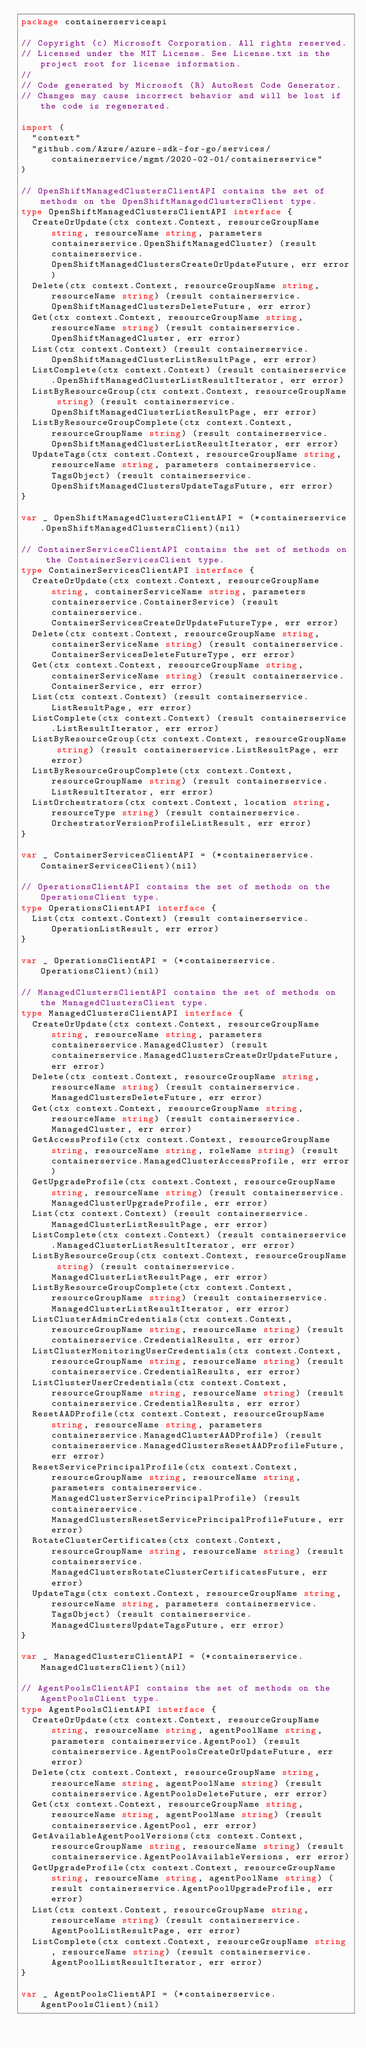Convert code to text. <code><loc_0><loc_0><loc_500><loc_500><_Go_>package containerserviceapi

// Copyright (c) Microsoft Corporation. All rights reserved.
// Licensed under the MIT License. See License.txt in the project root for license information.
//
// Code generated by Microsoft (R) AutoRest Code Generator.
// Changes may cause incorrect behavior and will be lost if the code is regenerated.

import (
	"context"
	"github.com/Azure/azure-sdk-for-go/services/containerservice/mgmt/2020-02-01/containerservice"
)

// OpenShiftManagedClustersClientAPI contains the set of methods on the OpenShiftManagedClustersClient type.
type OpenShiftManagedClustersClientAPI interface {
	CreateOrUpdate(ctx context.Context, resourceGroupName string, resourceName string, parameters containerservice.OpenShiftManagedCluster) (result containerservice.OpenShiftManagedClustersCreateOrUpdateFuture, err error)
	Delete(ctx context.Context, resourceGroupName string, resourceName string) (result containerservice.OpenShiftManagedClustersDeleteFuture, err error)
	Get(ctx context.Context, resourceGroupName string, resourceName string) (result containerservice.OpenShiftManagedCluster, err error)
	List(ctx context.Context) (result containerservice.OpenShiftManagedClusterListResultPage, err error)
	ListComplete(ctx context.Context) (result containerservice.OpenShiftManagedClusterListResultIterator, err error)
	ListByResourceGroup(ctx context.Context, resourceGroupName string) (result containerservice.OpenShiftManagedClusterListResultPage, err error)
	ListByResourceGroupComplete(ctx context.Context, resourceGroupName string) (result containerservice.OpenShiftManagedClusterListResultIterator, err error)
	UpdateTags(ctx context.Context, resourceGroupName string, resourceName string, parameters containerservice.TagsObject) (result containerservice.OpenShiftManagedClustersUpdateTagsFuture, err error)
}

var _ OpenShiftManagedClustersClientAPI = (*containerservice.OpenShiftManagedClustersClient)(nil)

// ContainerServicesClientAPI contains the set of methods on the ContainerServicesClient type.
type ContainerServicesClientAPI interface {
	CreateOrUpdate(ctx context.Context, resourceGroupName string, containerServiceName string, parameters containerservice.ContainerService) (result containerservice.ContainerServicesCreateOrUpdateFutureType, err error)
	Delete(ctx context.Context, resourceGroupName string, containerServiceName string) (result containerservice.ContainerServicesDeleteFutureType, err error)
	Get(ctx context.Context, resourceGroupName string, containerServiceName string) (result containerservice.ContainerService, err error)
	List(ctx context.Context) (result containerservice.ListResultPage, err error)
	ListComplete(ctx context.Context) (result containerservice.ListResultIterator, err error)
	ListByResourceGroup(ctx context.Context, resourceGroupName string) (result containerservice.ListResultPage, err error)
	ListByResourceGroupComplete(ctx context.Context, resourceGroupName string) (result containerservice.ListResultIterator, err error)
	ListOrchestrators(ctx context.Context, location string, resourceType string) (result containerservice.OrchestratorVersionProfileListResult, err error)
}

var _ ContainerServicesClientAPI = (*containerservice.ContainerServicesClient)(nil)

// OperationsClientAPI contains the set of methods on the OperationsClient type.
type OperationsClientAPI interface {
	List(ctx context.Context) (result containerservice.OperationListResult, err error)
}

var _ OperationsClientAPI = (*containerservice.OperationsClient)(nil)

// ManagedClustersClientAPI contains the set of methods on the ManagedClustersClient type.
type ManagedClustersClientAPI interface {
	CreateOrUpdate(ctx context.Context, resourceGroupName string, resourceName string, parameters containerservice.ManagedCluster) (result containerservice.ManagedClustersCreateOrUpdateFuture, err error)
	Delete(ctx context.Context, resourceGroupName string, resourceName string) (result containerservice.ManagedClustersDeleteFuture, err error)
	Get(ctx context.Context, resourceGroupName string, resourceName string) (result containerservice.ManagedCluster, err error)
	GetAccessProfile(ctx context.Context, resourceGroupName string, resourceName string, roleName string) (result containerservice.ManagedClusterAccessProfile, err error)
	GetUpgradeProfile(ctx context.Context, resourceGroupName string, resourceName string) (result containerservice.ManagedClusterUpgradeProfile, err error)
	List(ctx context.Context) (result containerservice.ManagedClusterListResultPage, err error)
	ListComplete(ctx context.Context) (result containerservice.ManagedClusterListResultIterator, err error)
	ListByResourceGroup(ctx context.Context, resourceGroupName string) (result containerservice.ManagedClusterListResultPage, err error)
	ListByResourceGroupComplete(ctx context.Context, resourceGroupName string) (result containerservice.ManagedClusterListResultIterator, err error)
	ListClusterAdminCredentials(ctx context.Context, resourceGroupName string, resourceName string) (result containerservice.CredentialResults, err error)
	ListClusterMonitoringUserCredentials(ctx context.Context, resourceGroupName string, resourceName string) (result containerservice.CredentialResults, err error)
	ListClusterUserCredentials(ctx context.Context, resourceGroupName string, resourceName string) (result containerservice.CredentialResults, err error)
	ResetAADProfile(ctx context.Context, resourceGroupName string, resourceName string, parameters containerservice.ManagedClusterAADProfile) (result containerservice.ManagedClustersResetAADProfileFuture, err error)
	ResetServicePrincipalProfile(ctx context.Context, resourceGroupName string, resourceName string, parameters containerservice.ManagedClusterServicePrincipalProfile) (result containerservice.ManagedClustersResetServicePrincipalProfileFuture, err error)
	RotateClusterCertificates(ctx context.Context, resourceGroupName string, resourceName string) (result containerservice.ManagedClustersRotateClusterCertificatesFuture, err error)
	UpdateTags(ctx context.Context, resourceGroupName string, resourceName string, parameters containerservice.TagsObject) (result containerservice.ManagedClustersUpdateTagsFuture, err error)
}

var _ ManagedClustersClientAPI = (*containerservice.ManagedClustersClient)(nil)

// AgentPoolsClientAPI contains the set of methods on the AgentPoolsClient type.
type AgentPoolsClientAPI interface {
	CreateOrUpdate(ctx context.Context, resourceGroupName string, resourceName string, agentPoolName string, parameters containerservice.AgentPool) (result containerservice.AgentPoolsCreateOrUpdateFuture, err error)
	Delete(ctx context.Context, resourceGroupName string, resourceName string, agentPoolName string) (result containerservice.AgentPoolsDeleteFuture, err error)
	Get(ctx context.Context, resourceGroupName string, resourceName string, agentPoolName string) (result containerservice.AgentPool, err error)
	GetAvailableAgentPoolVersions(ctx context.Context, resourceGroupName string, resourceName string) (result containerservice.AgentPoolAvailableVersions, err error)
	GetUpgradeProfile(ctx context.Context, resourceGroupName string, resourceName string, agentPoolName string) (result containerservice.AgentPoolUpgradeProfile, err error)
	List(ctx context.Context, resourceGroupName string, resourceName string) (result containerservice.AgentPoolListResultPage, err error)
	ListComplete(ctx context.Context, resourceGroupName string, resourceName string) (result containerservice.AgentPoolListResultIterator, err error)
}

var _ AgentPoolsClientAPI = (*containerservice.AgentPoolsClient)(nil)
</code> 